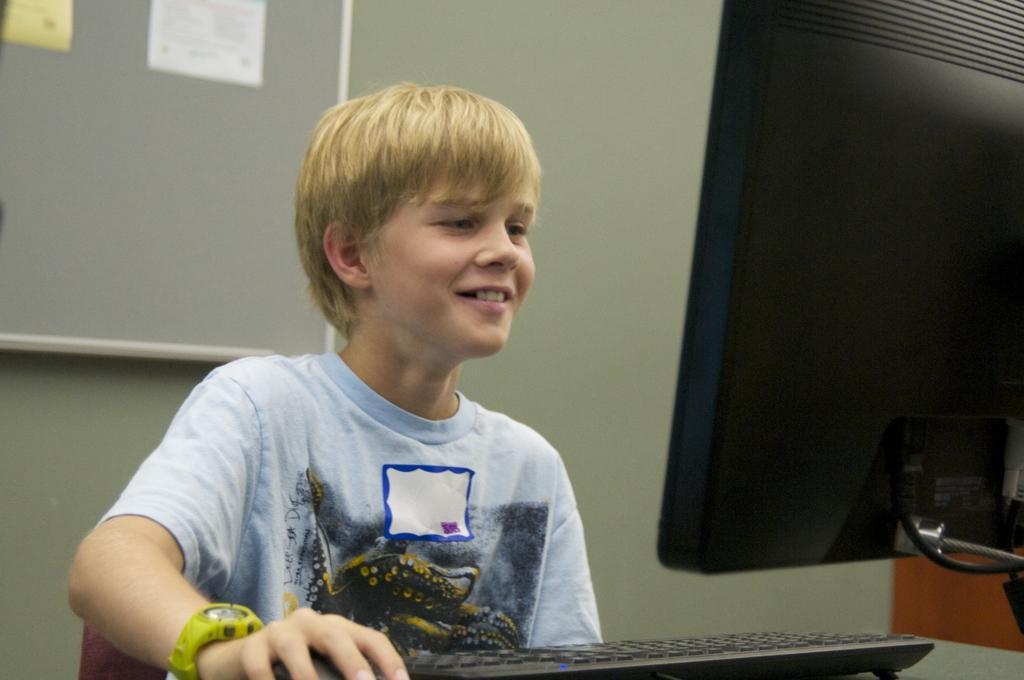How would you summarize this image in a sentence or two? In the middle of the image we can see a boy, he is smiling, in front of him we can see a monitor and keyboard, behind him we can see few papers on the notice board. 